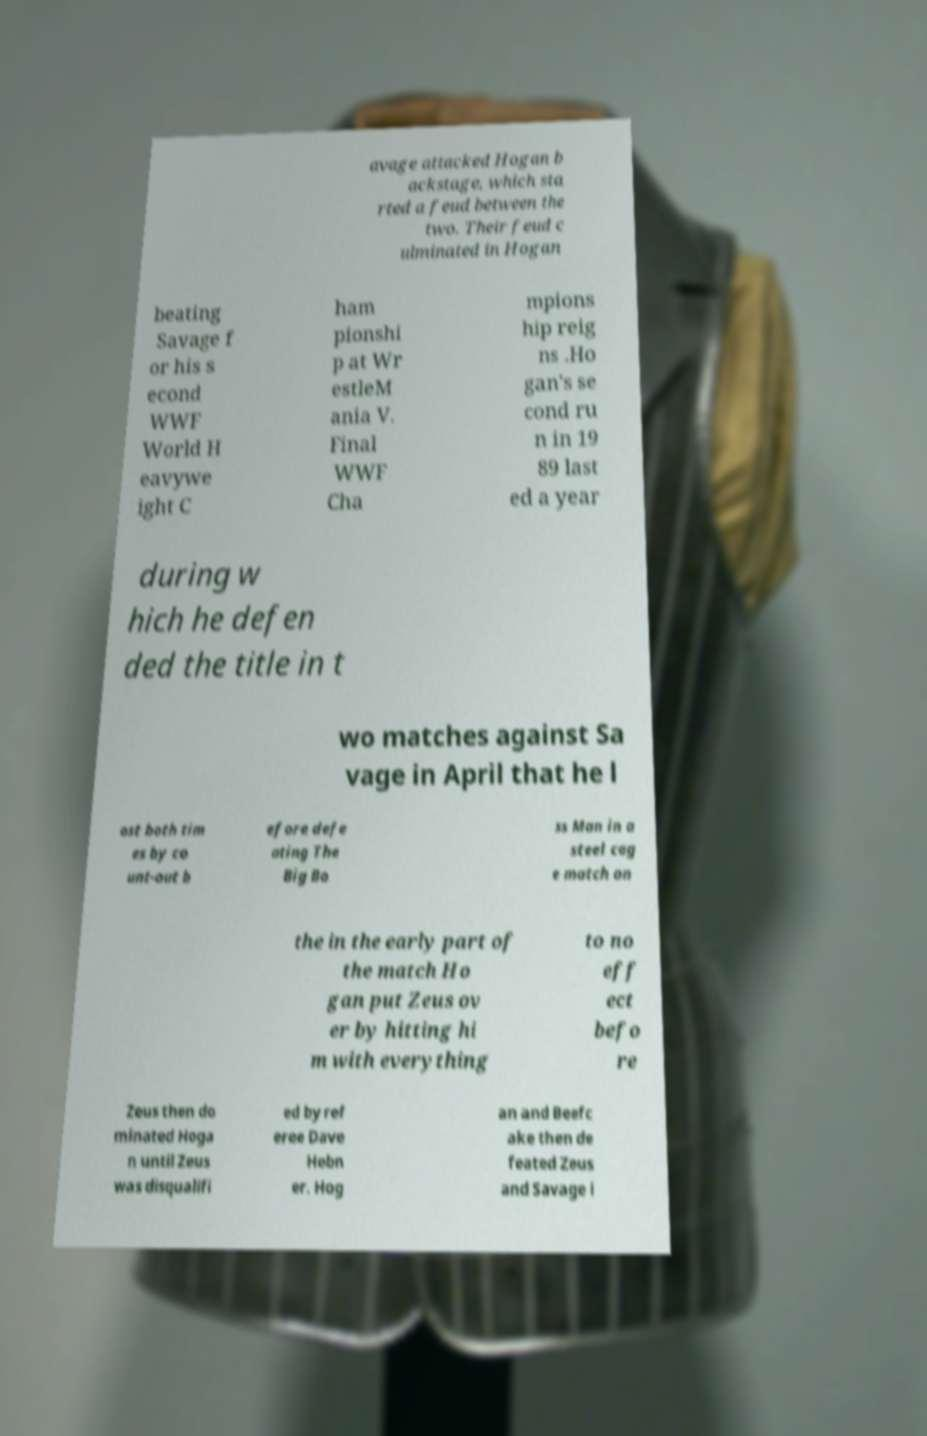I need the written content from this picture converted into text. Can you do that? avage attacked Hogan b ackstage, which sta rted a feud between the two. Their feud c ulminated in Hogan beating Savage f or his s econd WWF World H eavywe ight C ham pionshi p at Wr estleM ania V. Final WWF Cha mpions hip reig ns .Ho gan's se cond ru n in 19 89 last ed a year during w hich he defen ded the title in t wo matches against Sa vage in April that he l ost both tim es by co unt-out b efore defe ating The Big Bo ss Man in a steel cag e match on the in the early part of the match Ho gan put Zeus ov er by hitting hi m with everything to no eff ect befo re Zeus then do minated Hoga n until Zeus was disqualifi ed by ref eree Dave Hebn er. Hog an and Beefc ake then de feated Zeus and Savage i 